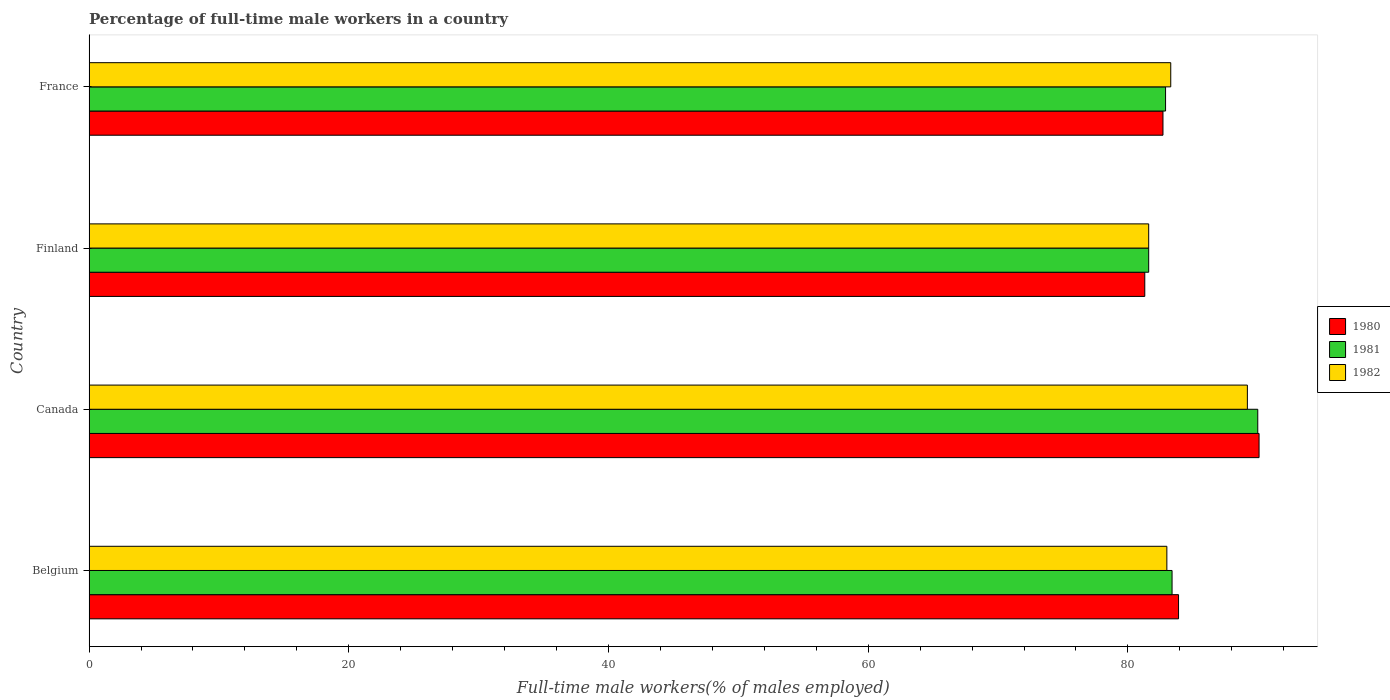Are the number of bars per tick equal to the number of legend labels?
Ensure brevity in your answer.  Yes. How many bars are there on the 2nd tick from the top?
Provide a short and direct response. 3. What is the label of the 2nd group of bars from the top?
Your response must be concise. Finland. What is the percentage of full-time male workers in 1981 in France?
Ensure brevity in your answer.  82.9. Across all countries, what is the maximum percentage of full-time male workers in 1980?
Provide a short and direct response. 90.1. Across all countries, what is the minimum percentage of full-time male workers in 1982?
Provide a short and direct response. 81.6. In which country was the percentage of full-time male workers in 1980 maximum?
Your answer should be very brief. Canada. What is the total percentage of full-time male workers in 1981 in the graph?
Give a very brief answer. 337.9. What is the difference between the percentage of full-time male workers in 1981 in Canada and that in Finland?
Provide a short and direct response. 8.4. What is the difference between the percentage of full-time male workers in 1981 in Finland and the percentage of full-time male workers in 1980 in France?
Make the answer very short. -1.1. What is the average percentage of full-time male workers in 1981 per country?
Give a very brief answer. 84.48. What is the difference between the percentage of full-time male workers in 1981 and percentage of full-time male workers in 1980 in Finland?
Provide a succinct answer. 0.3. What is the ratio of the percentage of full-time male workers in 1980 in Belgium to that in Finland?
Provide a short and direct response. 1.03. Is the percentage of full-time male workers in 1980 in Belgium less than that in France?
Offer a terse response. No. What is the difference between the highest and the second highest percentage of full-time male workers in 1980?
Provide a short and direct response. 6.2. What is the difference between the highest and the lowest percentage of full-time male workers in 1981?
Your answer should be very brief. 8.4. Is it the case that in every country, the sum of the percentage of full-time male workers in 1982 and percentage of full-time male workers in 1981 is greater than the percentage of full-time male workers in 1980?
Keep it short and to the point. Yes. Does the graph contain any zero values?
Ensure brevity in your answer.  No. What is the title of the graph?
Keep it short and to the point. Percentage of full-time male workers in a country. Does "1994" appear as one of the legend labels in the graph?
Ensure brevity in your answer.  No. What is the label or title of the X-axis?
Make the answer very short. Full-time male workers(% of males employed). What is the Full-time male workers(% of males employed) in 1980 in Belgium?
Keep it short and to the point. 83.9. What is the Full-time male workers(% of males employed) in 1981 in Belgium?
Your answer should be very brief. 83.4. What is the Full-time male workers(% of males employed) in 1980 in Canada?
Make the answer very short. 90.1. What is the Full-time male workers(% of males employed) of 1981 in Canada?
Make the answer very short. 90. What is the Full-time male workers(% of males employed) in 1982 in Canada?
Ensure brevity in your answer.  89.2. What is the Full-time male workers(% of males employed) of 1980 in Finland?
Provide a short and direct response. 81.3. What is the Full-time male workers(% of males employed) in 1981 in Finland?
Make the answer very short. 81.6. What is the Full-time male workers(% of males employed) of 1982 in Finland?
Your response must be concise. 81.6. What is the Full-time male workers(% of males employed) of 1980 in France?
Your answer should be very brief. 82.7. What is the Full-time male workers(% of males employed) in 1981 in France?
Keep it short and to the point. 82.9. What is the Full-time male workers(% of males employed) of 1982 in France?
Offer a very short reply. 83.3. Across all countries, what is the maximum Full-time male workers(% of males employed) in 1980?
Offer a very short reply. 90.1. Across all countries, what is the maximum Full-time male workers(% of males employed) in 1982?
Offer a very short reply. 89.2. Across all countries, what is the minimum Full-time male workers(% of males employed) of 1980?
Your response must be concise. 81.3. Across all countries, what is the minimum Full-time male workers(% of males employed) of 1981?
Your response must be concise. 81.6. Across all countries, what is the minimum Full-time male workers(% of males employed) of 1982?
Your answer should be very brief. 81.6. What is the total Full-time male workers(% of males employed) of 1980 in the graph?
Make the answer very short. 338. What is the total Full-time male workers(% of males employed) of 1981 in the graph?
Make the answer very short. 337.9. What is the total Full-time male workers(% of males employed) in 1982 in the graph?
Keep it short and to the point. 337.1. What is the difference between the Full-time male workers(% of males employed) of 1980 in Belgium and that in Canada?
Make the answer very short. -6.2. What is the difference between the Full-time male workers(% of males employed) in 1981 in Belgium and that in Canada?
Provide a short and direct response. -6.6. What is the difference between the Full-time male workers(% of males employed) in 1982 in Belgium and that in Canada?
Your answer should be very brief. -6.2. What is the difference between the Full-time male workers(% of males employed) in 1981 in Belgium and that in Finland?
Make the answer very short. 1.8. What is the difference between the Full-time male workers(% of males employed) in 1980 in Belgium and that in France?
Keep it short and to the point. 1.2. What is the difference between the Full-time male workers(% of males employed) in 1981 in Belgium and that in France?
Offer a terse response. 0.5. What is the difference between the Full-time male workers(% of males employed) of 1980 in Canada and that in Finland?
Provide a short and direct response. 8.8. What is the difference between the Full-time male workers(% of males employed) in 1982 in Canada and that in Finland?
Make the answer very short. 7.6. What is the difference between the Full-time male workers(% of males employed) of 1980 in Canada and that in France?
Your answer should be very brief. 7.4. What is the difference between the Full-time male workers(% of males employed) of 1981 in Canada and that in France?
Provide a short and direct response. 7.1. What is the difference between the Full-time male workers(% of males employed) in 1980 in Finland and that in France?
Offer a terse response. -1.4. What is the difference between the Full-time male workers(% of males employed) of 1981 in Finland and that in France?
Your answer should be compact. -1.3. What is the difference between the Full-time male workers(% of males employed) in 1982 in Finland and that in France?
Provide a succinct answer. -1.7. What is the difference between the Full-time male workers(% of males employed) of 1980 in Belgium and the Full-time male workers(% of males employed) of 1981 in Canada?
Your answer should be very brief. -6.1. What is the difference between the Full-time male workers(% of males employed) of 1980 in Belgium and the Full-time male workers(% of males employed) of 1981 in France?
Provide a succinct answer. 1. What is the difference between the Full-time male workers(% of males employed) of 1981 in Belgium and the Full-time male workers(% of males employed) of 1982 in France?
Provide a succinct answer. 0.1. What is the difference between the Full-time male workers(% of males employed) of 1981 in Canada and the Full-time male workers(% of males employed) of 1982 in France?
Offer a very short reply. 6.7. What is the difference between the Full-time male workers(% of males employed) of 1980 in Finland and the Full-time male workers(% of males employed) of 1982 in France?
Your answer should be compact. -2. What is the difference between the Full-time male workers(% of males employed) in 1981 in Finland and the Full-time male workers(% of males employed) in 1982 in France?
Ensure brevity in your answer.  -1.7. What is the average Full-time male workers(% of males employed) of 1980 per country?
Offer a very short reply. 84.5. What is the average Full-time male workers(% of males employed) of 1981 per country?
Your answer should be compact. 84.47. What is the average Full-time male workers(% of males employed) in 1982 per country?
Give a very brief answer. 84.28. What is the difference between the Full-time male workers(% of males employed) in 1980 and Full-time male workers(% of males employed) in 1982 in Belgium?
Provide a succinct answer. 0.9. What is the difference between the Full-time male workers(% of males employed) of 1981 and Full-time male workers(% of males employed) of 1982 in Belgium?
Give a very brief answer. 0.4. What is the difference between the Full-time male workers(% of males employed) of 1980 and Full-time male workers(% of males employed) of 1981 in Canada?
Provide a succinct answer. 0.1. What is the difference between the Full-time male workers(% of males employed) in 1980 and Full-time male workers(% of males employed) in 1982 in Finland?
Keep it short and to the point. -0.3. What is the difference between the Full-time male workers(% of males employed) of 1981 and Full-time male workers(% of males employed) of 1982 in Finland?
Offer a terse response. 0. What is the difference between the Full-time male workers(% of males employed) in 1980 and Full-time male workers(% of males employed) in 1981 in France?
Your response must be concise. -0.2. What is the difference between the Full-time male workers(% of males employed) of 1980 and Full-time male workers(% of males employed) of 1982 in France?
Your answer should be very brief. -0.6. What is the ratio of the Full-time male workers(% of males employed) of 1980 in Belgium to that in Canada?
Provide a short and direct response. 0.93. What is the ratio of the Full-time male workers(% of males employed) in 1981 in Belgium to that in Canada?
Make the answer very short. 0.93. What is the ratio of the Full-time male workers(% of males employed) in 1982 in Belgium to that in Canada?
Make the answer very short. 0.93. What is the ratio of the Full-time male workers(% of males employed) in 1980 in Belgium to that in Finland?
Your answer should be compact. 1.03. What is the ratio of the Full-time male workers(% of males employed) of 1981 in Belgium to that in Finland?
Your answer should be very brief. 1.02. What is the ratio of the Full-time male workers(% of males employed) of 1982 in Belgium to that in Finland?
Give a very brief answer. 1.02. What is the ratio of the Full-time male workers(% of males employed) in 1980 in Belgium to that in France?
Your answer should be compact. 1.01. What is the ratio of the Full-time male workers(% of males employed) in 1980 in Canada to that in Finland?
Your response must be concise. 1.11. What is the ratio of the Full-time male workers(% of males employed) of 1981 in Canada to that in Finland?
Your response must be concise. 1.1. What is the ratio of the Full-time male workers(% of males employed) of 1982 in Canada to that in Finland?
Offer a very short reply. 1.09. What is the ratio of the Full-time male workers(% of males employed) of 1980 in Canada to that in France?
Provide a succinct answer. 1.09. What is the ratio of the Full-time male workers(% of males employed) of 1981 in Canada to that in France?
Ensure brevity in your answer.  1.09. What is the ratio of the Full-time male workers(% of males employed) of 1982 in Canada to that in France?
Offer a terse response. 1.07. What is the ratio of the Full-time male workers(% of males employed) of 1980 in Finland to that in France?
Provide a succinct answer. 0.98. What is the ratio of the Full-time male workers(% of males employed) in 1981 in Finland to that in France?
Your answer should be compact. 0.98. What is the ratio of the Full-time male workers(% of males employed) in 1982 in Finland to that in France?
Provide a short and direct response. 0.98. What is the difference between the highest and the second highest Full-time male workers(% of males employed) in 1981?
Give a very brief answer. 6.6. What is the difference between the highest and the second highest Full-time male workers(% of males employed) of 1982?
Provide a succinct answer. 5.9. What is the difference between the highest and the lowest Full-time male workers(% of males employed) of 1981?
Give a very brief answer. 8.4. 